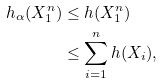<formula> <loc_0><loc_0><loc_500><loc_500>h _ { \alpha } ( X _ { 1 } ^ { n } ) & \leq h ( X _ { 1 } ^ { n } ) \\ & \leq \sum _ { i = 1 } ^ { n } h ( X _ { i } ) ,</formula> 